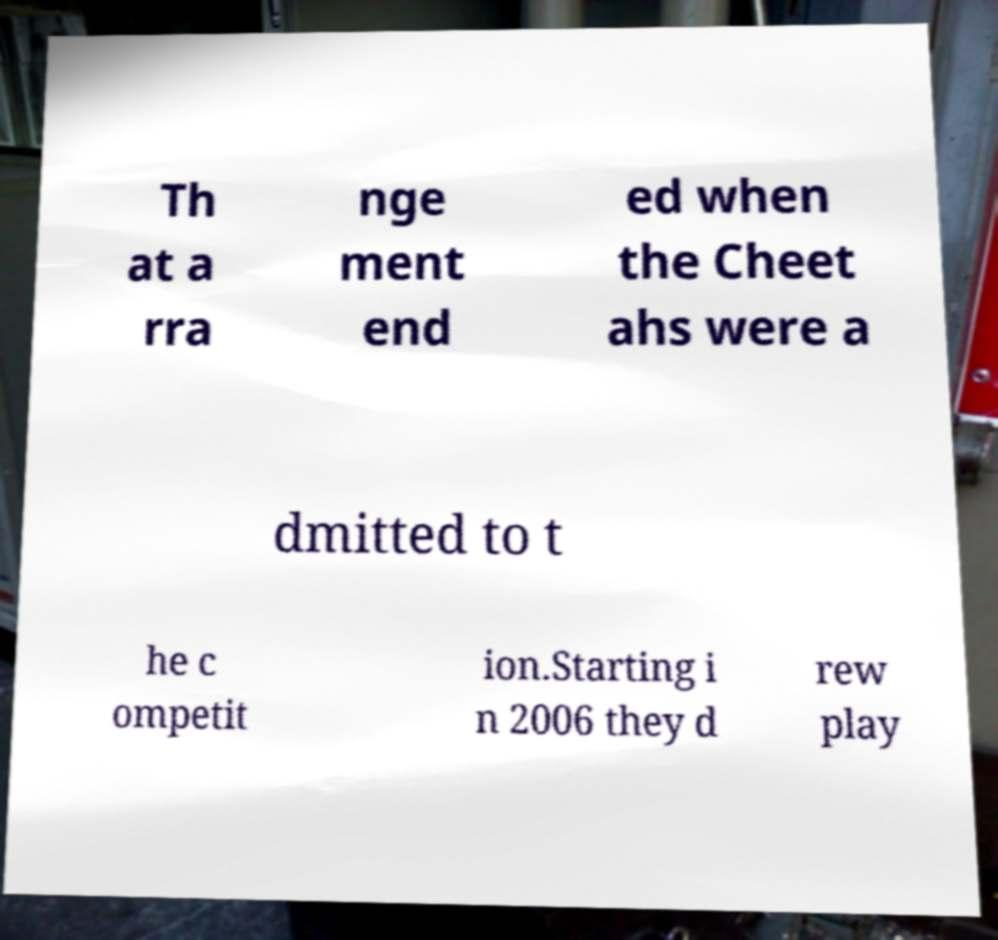Please identify and transcribe the text found in this image. Th at a rra nge ment end ed when the Cheet ahs were a dmitted to t he c ompetit ion.Starting i n 2006 they d rew play 